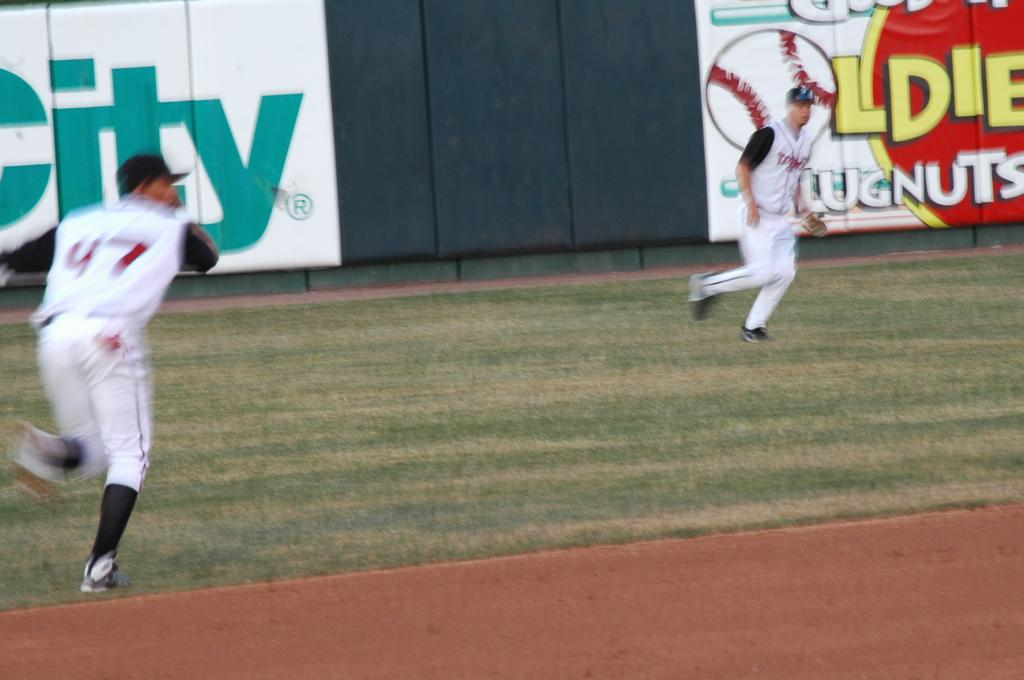<image>
Present a compact description of the photo's key features. number 47 running to catch a ball in front of city sign 